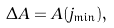Convert formula to latex. <formula><loc_0><loc_0><loc_500><loc_500>\Delta A = A ( j _ { \min } ) ,</formula> 